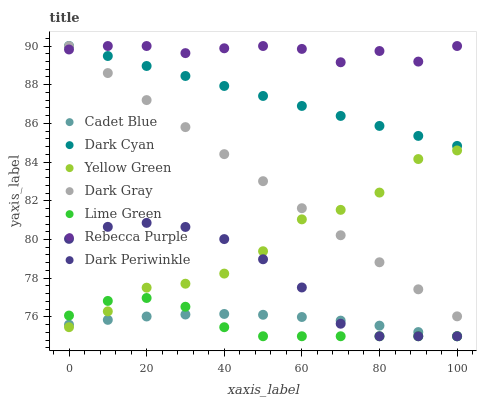Does Lime Green have the minimum area under the curve?
Answer yes or no. Yes. Does Rebecca Purple have the maximum area under the curve?
Answer yes or no. Yes. Does Yellow Green have the minimum area under the curve?
Answer yes or no. No. Does Yellow Green have the maximum area under the curve?
Answer yes or no. No. Is Dark Cyan the smoothest?
Answer yes or no. Yes. Is Yellow Green the roughest?
Answer yes or no. Yes. Is Dark Gray the smoothest?
Answer yes or no. No. Is Dark Gray the roughest?
Answer yes or no. No. Does Cadet Blue have the lowest value?
Answer yes or no. Yes. Does Yellow Green have the lowest value?
Answer yes or no. No. Does Dark Cyan have the highest value?
Answer yes or no. Yes. Does Yellow Green have the highest value?
Answer yes or no. No. Is Dark Periwinkle less than Dark Cyan?
Answer yes or no. Yes. Is Rebecca Purple greater than Lime Green?
Answer yes or no. Yes. Does Dark Periwinkle intersect Lime Green?
Answer yes or no. Yes. Is Dark Periwinkle less than Lime Green?
Answer yes or no. No. Is Dark Periwinkle greater than Lime Green?
Answer yes or no. No. Does Dark Periwinkle intersect Dark Cyan?
Answer yes or no. No. 